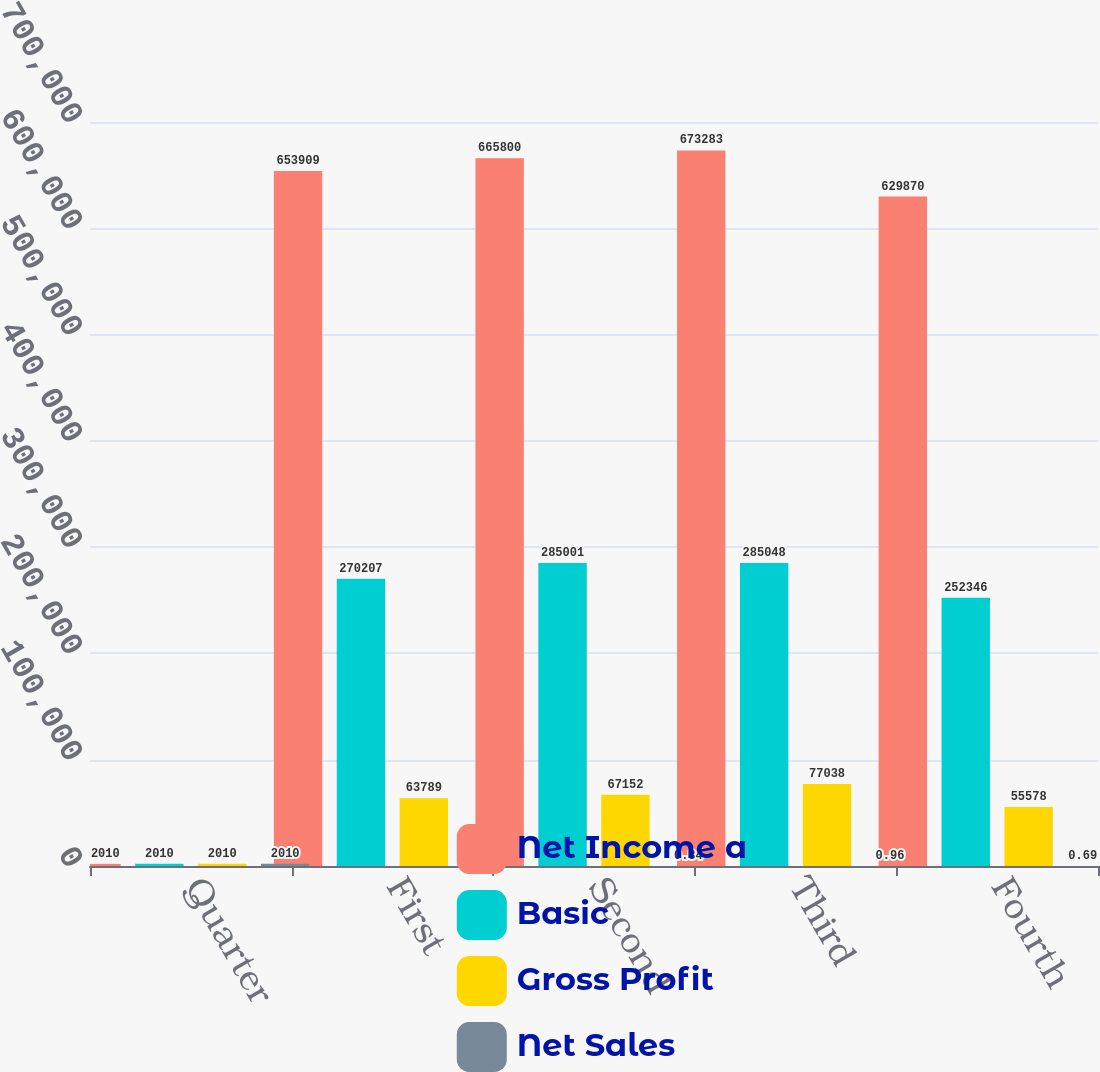<chart> <loc_0><loc_0><loc_500><loc_500><stacked_bar_chart><ecel><fcel>Quarter<fcel>First<fcel>Second<fcel>Third<fcel>Fourth<nl><fcel>Net Income a<fcel>2010<fcel>653909<fcel>665800<fcel>673283<fcel>629870<nl><fcel>Basic<fcel>2010<fcel>270207<fcel>285001<fcel>285048<fcel>252346<nl><fcel>Gross Profit<fcel>2010<fcel>63789<fcel>67152<fcel>77038<fcel>55578<nl><fcel>Net Sales<fcel>2010<fcel>0.8<fcel>0.84<fcel>0.96<fcel>0.69<nl></chart> 